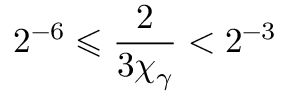<formula> <loc_0><loc_0><loc_500><loc_500>2 ^ { - 6 } \leqslant \frac { 2 } { 3 \chi _ { \gamma } } < 2 ^ { - 3 }</formula> 